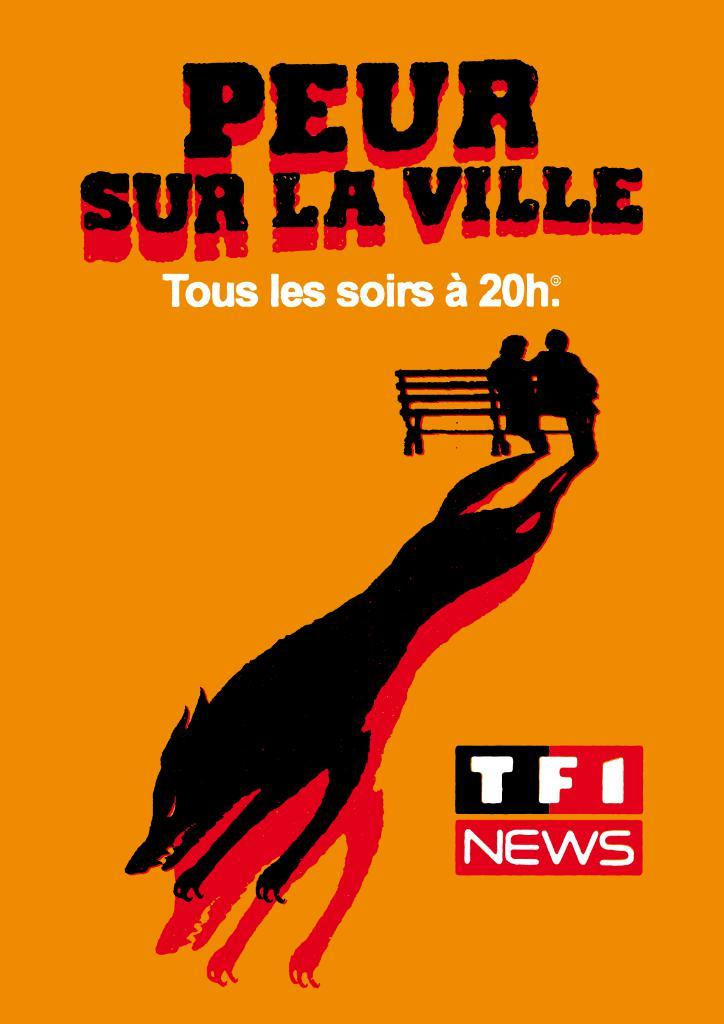What is featured in the image? There is a poster in the image. What is shown on the poster? The poster depicts two people sitting on a bench. What type of floor can be seen beneath the bench in the image? There is no floor visible in the image, as the poster only shows the two people sitting on a bench. 